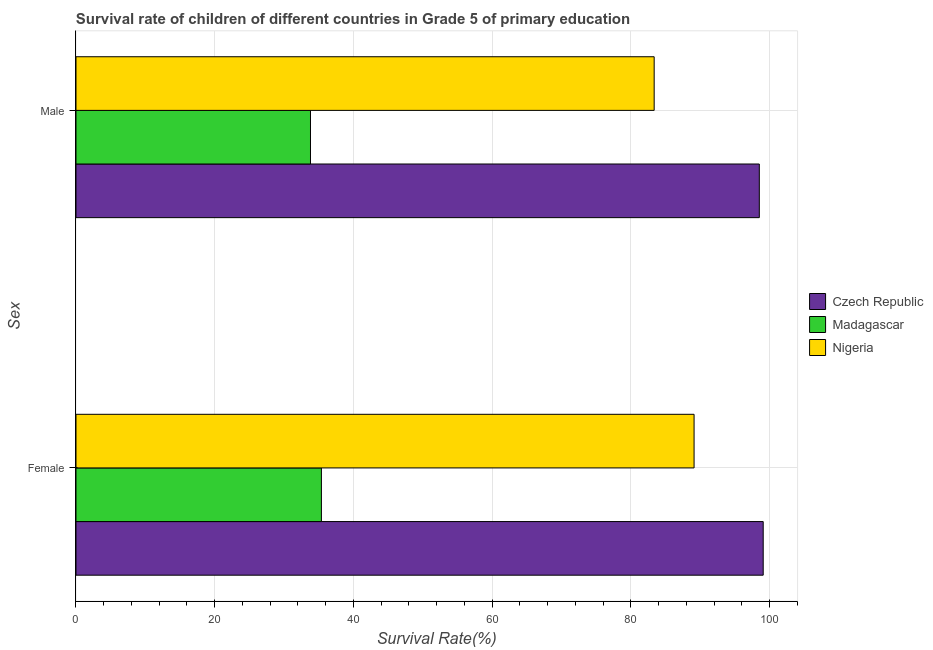How many groups of bars are there?
Ensure brevity in your answer.  2. Are the number of bars per tick equal to the number of legend labels?
Make the answer very short. Yes. What is the label of the 1st group of bars from the top?
Offer a very short reply. Male. What is the survival rate of female students in primary education in Nigeria?
Give a very brief answer. 89.1. Across all countries, what is the maximum survival rate of male students in primary education?
Ensure brevity in your answer.  98.51. Across all countries, what is the minimum survival rate of female students in primary education?
Keep it short and to the point. 35.38. In which country was the survival rate of female students in primary education maximum?
Your response must be concise. Czech Republic. In which country was the survival rate of female students in primary education minimum?
Offer a terse response. Madagascar. What is the total survival rate of male students in primary education in the graph?
Keep it short and to the point. 215.66. What is the difference between the survival rate of male students in primary education in Nigeria and that in Czech Republic?
Provide a short and direct response. -15.16. What is the difference between the survival rate of female students in primary education in Nigeria and the survival rate of male students in primary education in Madagascar?
Ensure brevity in your answer.  55.3. What is the average survival rate of female students in primary education per country?
Ensure brevity in your answer.  74.52. What is the difference between the survival rate of female students in primary education and survival rate of male students in primary education in Madagascar?
Your answer should be compact. 1.58. In how many countries, is the survival rate of male students in primary education greater than 48 %?
Keep it short and to the point. 2. What is the ratio of the survival rate of female students in primary education in Czech Republic to that in Madagascar?
Provide a succinct answer. 2.8. What does the 1st bar from the top in Male represents?
Your answer should be very brief. Nigeria. What does the 1st bar from the bottom in Male represents?
Provide a short and direct response. Czech Republic. How many bars are there?
Offer a terse response. 6. Where does the legend appear in the graph?
Offer a terse response. Center right. What is the title of the graph?
Your answer should be very brief. Survival rate of children of different countries in Grade 5 of primary education. What is the label or title of the X-axis?
Offer a terse response. Survival Rate(%). What is the label or title of the Y-axis?
Provide a short and direct response. Sex. What is the Survival Rate(%) in Czech Republic in Female?
Your answer should be compact. 99.07. What is the Survival Rate(%) of Madagascar in Female?
Ensure brevity in your answer.  35.38. What is the Survival Rate(%) in Nigeria in Female?
Ensure brevity in your answer.  89.1. What is the Survival Rate(%) of Czech Republic in Male?
Ensure brevity in your answer.  98.51. What is the Survival Rate(%) in Madagascar in Male?
Make the answer very short. 33.8. What is the Survival Rate(%) in Nigeria in Male?
Ensure brevity in your answer.  83.35. Across all Sex, what is the maximum Survival Rate(%) in Czech Republic?
Your response must be concise. 99.07. Across all Sex, what is the maximum Survival Rate(%) of Madagascar?
Keep it short and to the point. 35.38. Across all Sex, what is the maximum Survival Rate(%) in Nigeria?
Provide a short and direct response. 89.1. Across all Sex, what is the minimum Survival Rate(%) in Czech Republic?
Provide a short and direct response. 98.51. Across all Sex, what is the minimum Survival Rate(%) of Madagascar?
Offer a terse response. 33.8. Across all Sex, what is the minimum Survival Rate(%) of Nigeria?
Offer a terse response. 83.35. What is the total Survival Rate(%) of Czech Republic in the graph?
Give a very brief answer. 197.58. What is the total Survival Rate(%) in Madagascar in the graph?
Keep it short and to the point. 69.18. What is the total Survival Rate(%) in Nigeria in the graph?
Your answer should be very brief. 172.45. What is the difference between the Survival Rate(%) in Czech Republic in Female and that in Male?
Give a very brief answer. 0.56. What is the difference between the Survival Rate(%) of Madagascar in Female and that in Male?
Your response must be concise. 1.58. What is the difference between the Survival Rate(%) in Nigeria in Female and that in Male?
Offer a terse response. 5.75. What is the difference between the Survival Rate(%) of Czech Republic in Female and the Survival Rate(%) of Madagascar in Male?
Make the answer very short. 65.27. What is the difference between the Survival Rate(%) in Czech Republic in Female and the Survival Rate(%) in Nigeria in Male?
Your answer should be very brief. 15.72. What is the difference between the Survival Rate(%) in Madagascar in Female and the Survival Rate(%) in Nigeria in Male?
Give a very brief answer. -47.97. What is the average Survival Rate(%) in Czech Republic per Sex?
Keep it short and to the point. 98.79. What is the average Survival Rate(%) of Madagascar per Sex?
Provide a succinct answer. 34.59. What is the average Survival Rate(%) in Nigeria per Sex?
Your answer should be compact. 86.23. What is the difference between the Survival Rate(%) of Czech Republic and Survival Rate(%) of Madagascar in Female?
Offer a terse response. 63.69. What is the difference between the Survival Rate(%) of Czech Republic and Survival Rate(%) of Nigeria in Female?
Offer a very short reply. 9.97. What is the difference between the Survival Rate(%) in Madagascar and Survival Rate(%) in Nigeria in Female?
Keep it short and to the point. -53.72. What is the difference between the Survival Rate(%) in Czech Republic and Survival Rate(%) in Madagascar in Male?
Give a very brief answer. 64.7. What is the difference between the Survival Rate(%) of Czech Republic and Survival Rate(%) of Nigeria in Male?
Provide a short and direct response. 15.16. What is the difference between the Survival Rate(%) of Madagascar and Survival Rate(%) of Nigeria in Male?
Offer a very short reply. -49.55. What is the ratio of the Survival Rate(%) in Czech Republic in Female to that in Male?
Give a very brief answer. 1.01. What is the ratio of the Survival Rate(%) in Madagascar in Female to that in Male?
Offer a very short reply. 1.05. What is the ratio of the Survival Rate(%) of Nigeria in Female to that in Male?
Offer a very short reply. 1.07. What is the difference between the highest and the second highest Survival Rate(%) in Czech Republic?
Keep it short and to the point. 0.56. What is the difference between the highest and the second highest Survival Rate(%) in Madagascar?
Your answer should be compact. 1.58. What is the difference between the highest and the second highest Survival Rate(%) in Nigeria?
Provide a short and direct response. 5.75. What is the difference between the highest and the lowest Survival Rate(%) of Czech Republic?
Provide a succinct answer. 0.56. What is the difference between the highest and the lowest Survival Rate(%) in Madagascar?
Offer a terse response. 1.58. What is the difference between the highest and the lowest Survival Rate(%) in Nigeria?
Make the answer very short. 5.75. 